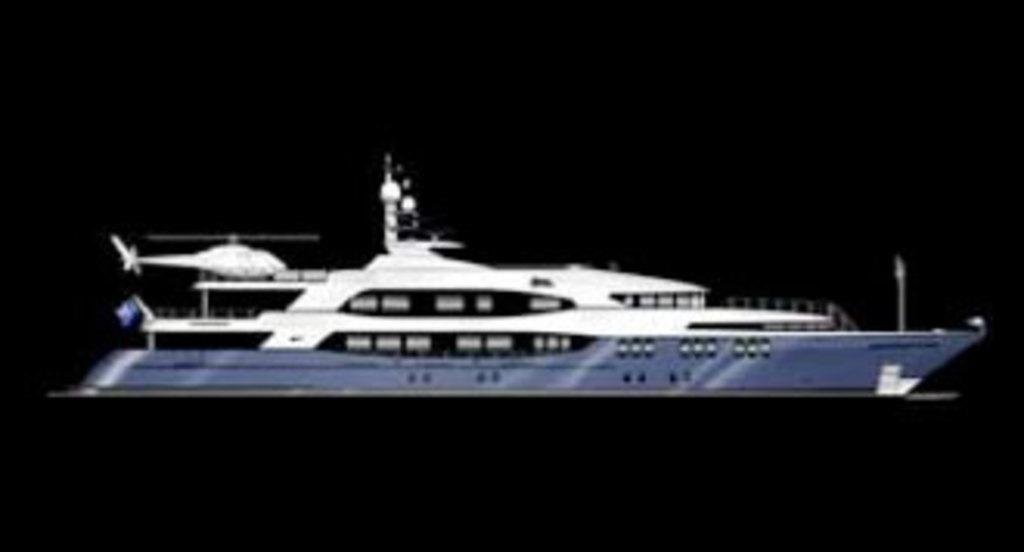What is the main subject of the image? The main subject of the image is a ship. Are there any other vehicles or objects present in the image? Yes, there is a helicopter in the image. What type of brush is being used to paint the bridge in the image? There is no bridge or brush present in the image; it features a ship and a helicopter. 